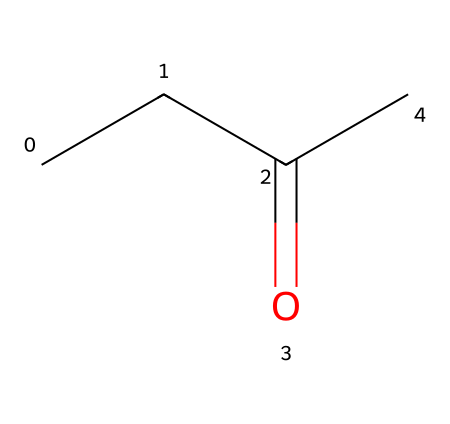What is the molecular formula of methyl ethyl ketone? To determine the molecular formula from the SMILES representation, count the number of each type of atom present. The representation CCC(=O)C corresponds to 4 carbon (C) atoms and 8 hydrogen (H) atoms, leading to the formula C4H8O.
Answer: C4H8O How many carbon atoms are present in the structure? The SMILES representation shows "CCC" at the beginning indicating three carbon atoms connected in a chain, and there is one additional carbon from "C" after the carbonyl (C=O), totaling 4 carbon atoms.
Answer: 4 What type of bond is present between the carbonyl carbon and the oxygen? The presence of "C(=O)" indicates a double bond between the carbon and the oxygen in the carbonyl group, which is characteristic of ketones.
Answer: double bond What is the functional group present in methyl ethyl ketone? The SMILES shows "C(=O)" which identifies the carbonyl group (C=O). In ketones, this functional group is situated between two alkyl groups, confirming it is a ketone.
Answer: carbonyl group Is methyl ethyl ketone a polar or non-polar compound? Considering the presence of the polar carbonyl group and the alkyl chains that are relatively non-polar, the overall molecule displays polar characteristics due to the carbonyl's electronegativity.
Answer: polar How many hydrogen atoms are bonded to the central carbon atom in MEK? Look at the structure; the central carbon is part of the carbonyl (C=O) group and bonded to two other carbons while not being directly connected to any hydrogens. Therefore, it has no hydrogen atoms directly attached.
Answer: 0 